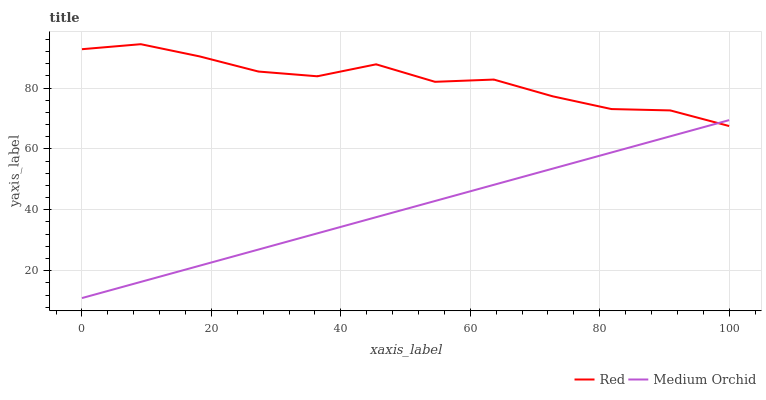Does Red have the minimum area under the curve?
Answer yes or no. No. Is Red the smoothest?
Answer yes or no. No. Does Red have the lowest value?
Answer yes or no. No. 